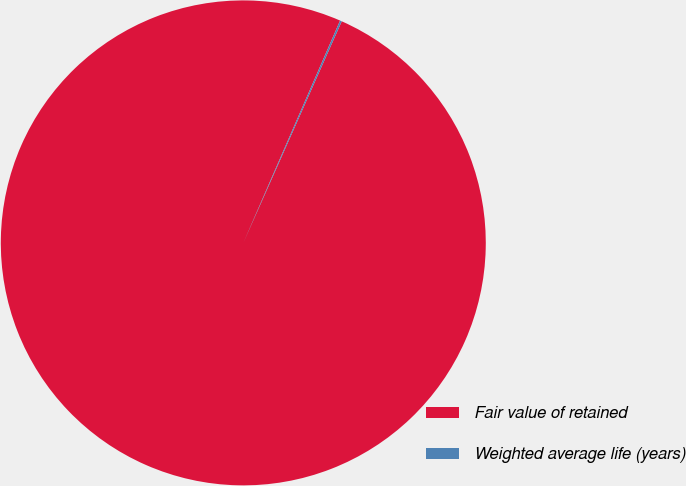Convert chart. <chart><loc_0><loc_0><loc_500><loc_500><pie_chart><fcel>Fair value of retained<fcel>Weighted average life (years)<nl><fcel>99.88%<fcel>0.12%<nl></chart> 